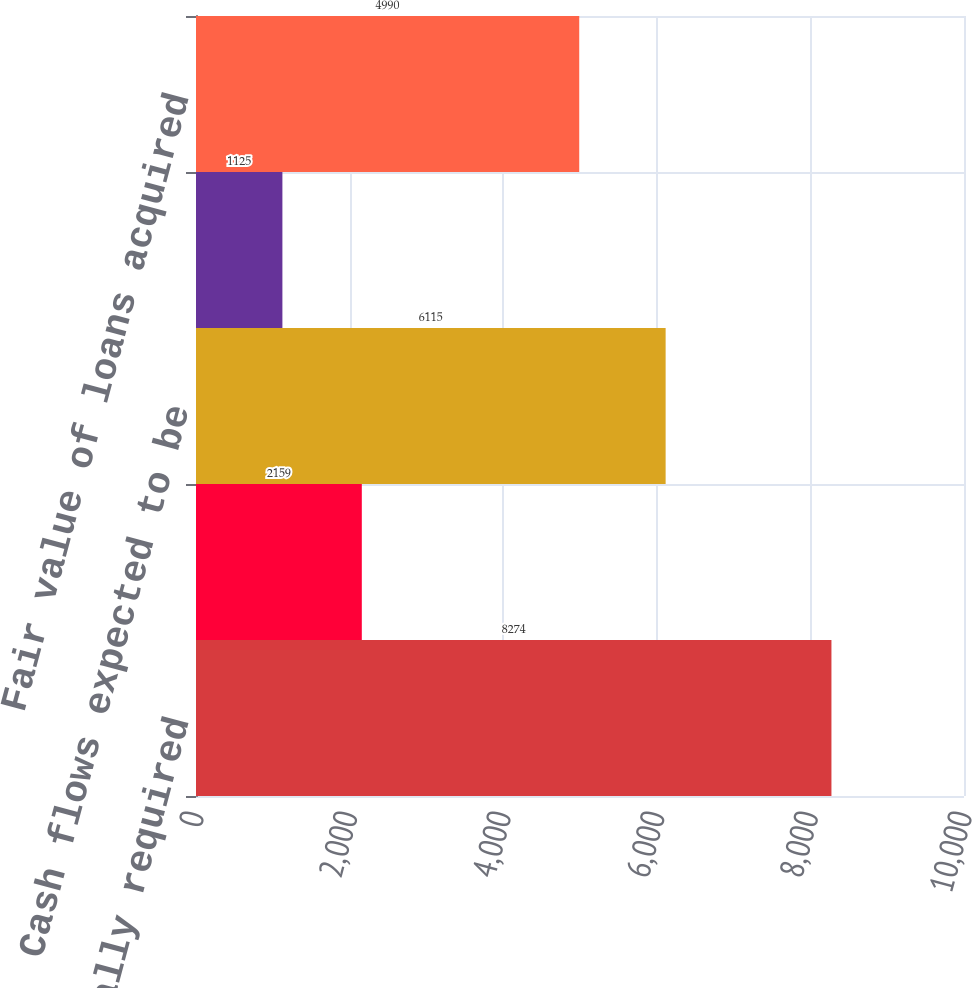Convert chart. <chart><loc_0><loc_0><loc_500><loc_500><bar_chart><fcel>Contractually required<fcel>Less Nonaccretable difference<fcel>Cash flows expected to be<fcel>Less Accretable yield<fcel>Fair value of loans acquired<nl><fcel>8274<fcel>2159<fcel>6115<fcel>1125<fcel>4990<nl></chart> 